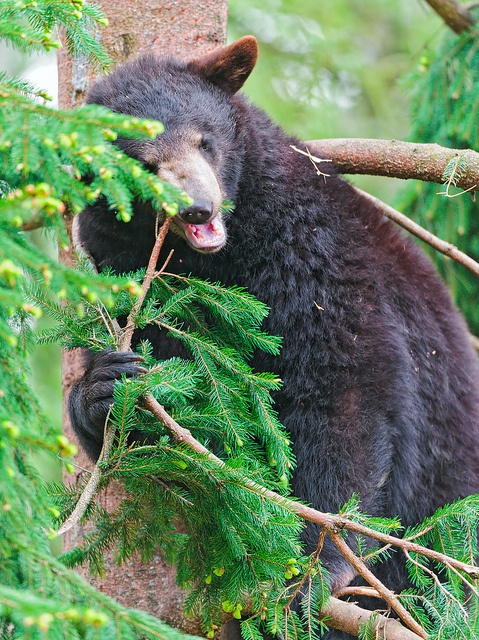Describe the objects in this image and their specific colors. I can see a bear in lightgreen, gray, black, and darkgray tones in this image. 